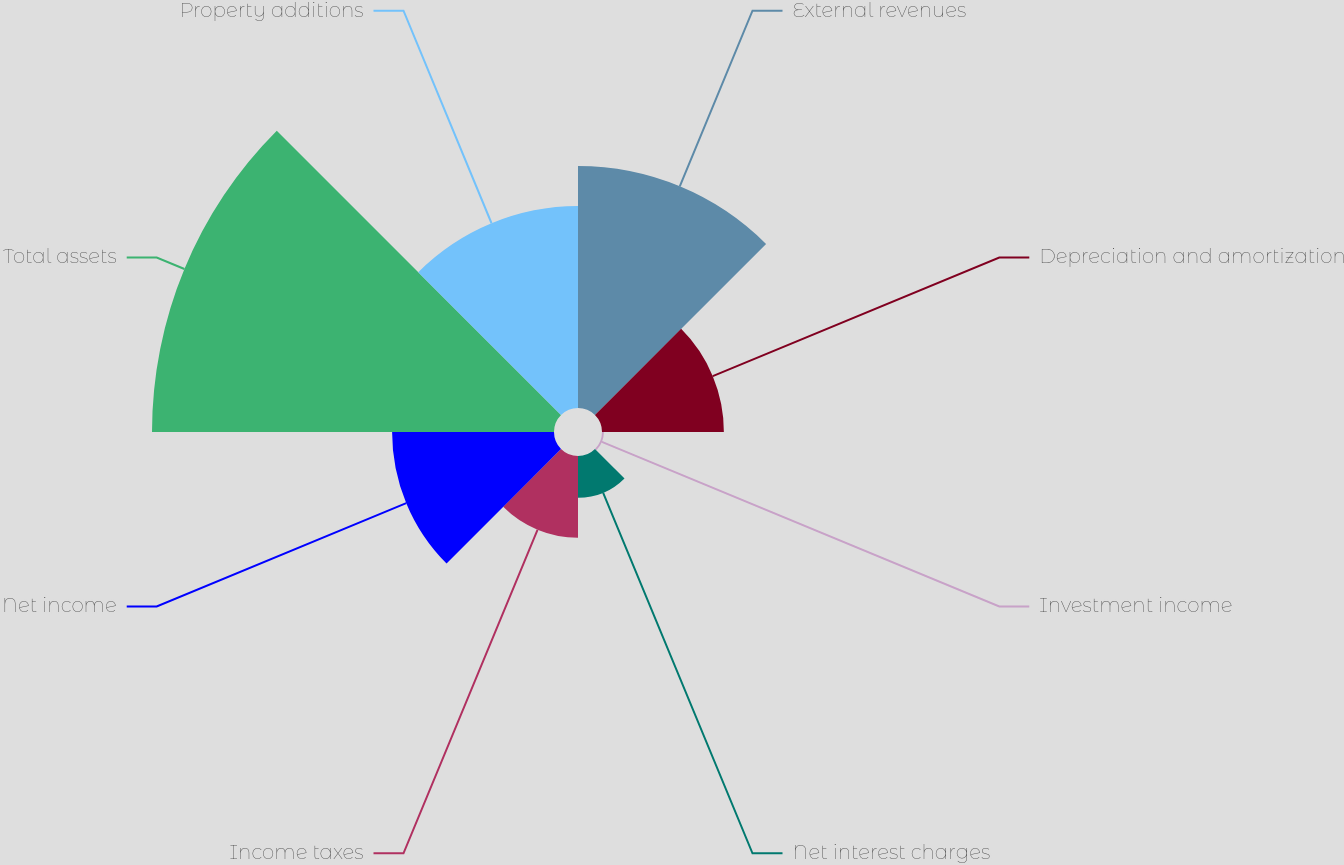<chart> <loc_0><loc_0><loc_500><loc_500><pie_chart><fcel>External revenues<fcel>Depreciation and amortization<fcel>Investment income<fcel>Net interest charges<fcel>Income taxes<fcel>Net income<fcel>Total assets<fcel>Property additions<nl><fcel>19.28%<fcel>9.71%<fcel>0.15%<fcel>3.33%<fcel>6.52%<fcel>12.9%<fcel>32.03%<fcel>16.09%<nl></chart> 